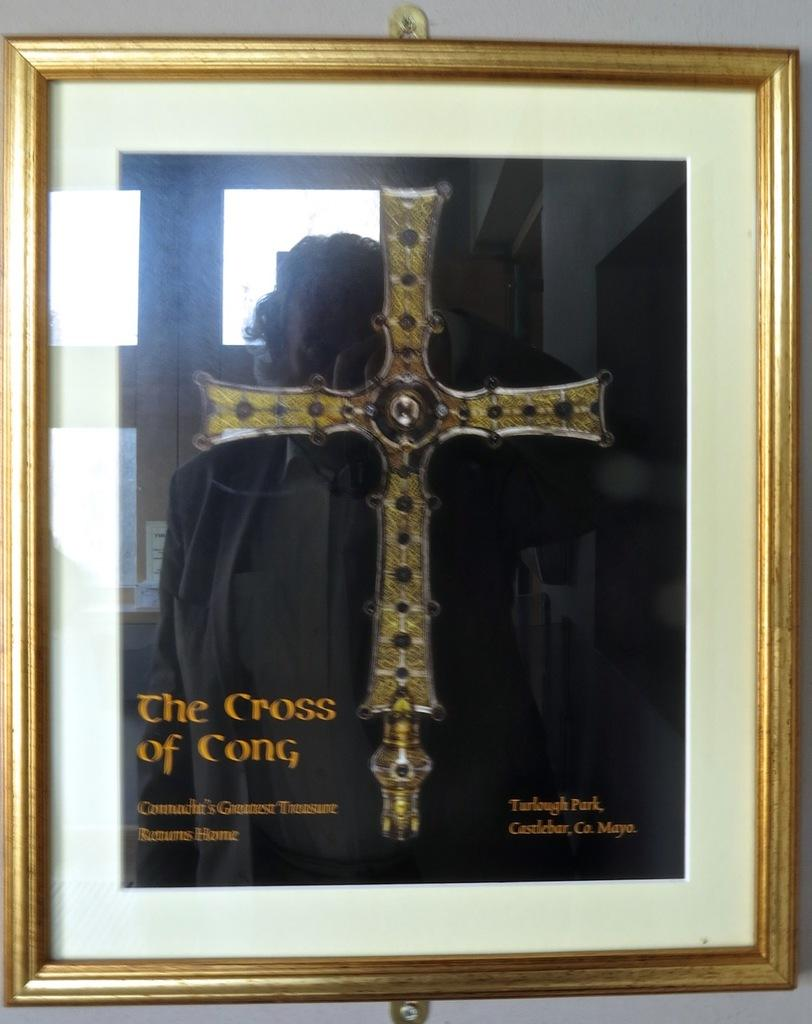What is hanging on the wall in the image? There is a photo frame on the wall. What is depicted inside the photo frame? The photo frame contains a cross. Are there any words or letters in the photo frame? Yes, there is text in the photo frame. What type of good-bye message is written on the wall next to the photo frame? There is no good-bye message present in the image; it only features a photo frame with a cross and text. Can you see a giraffe in the photo frame? No, there is no giraffe depicted in the photo frame; it contains a cross and text. 